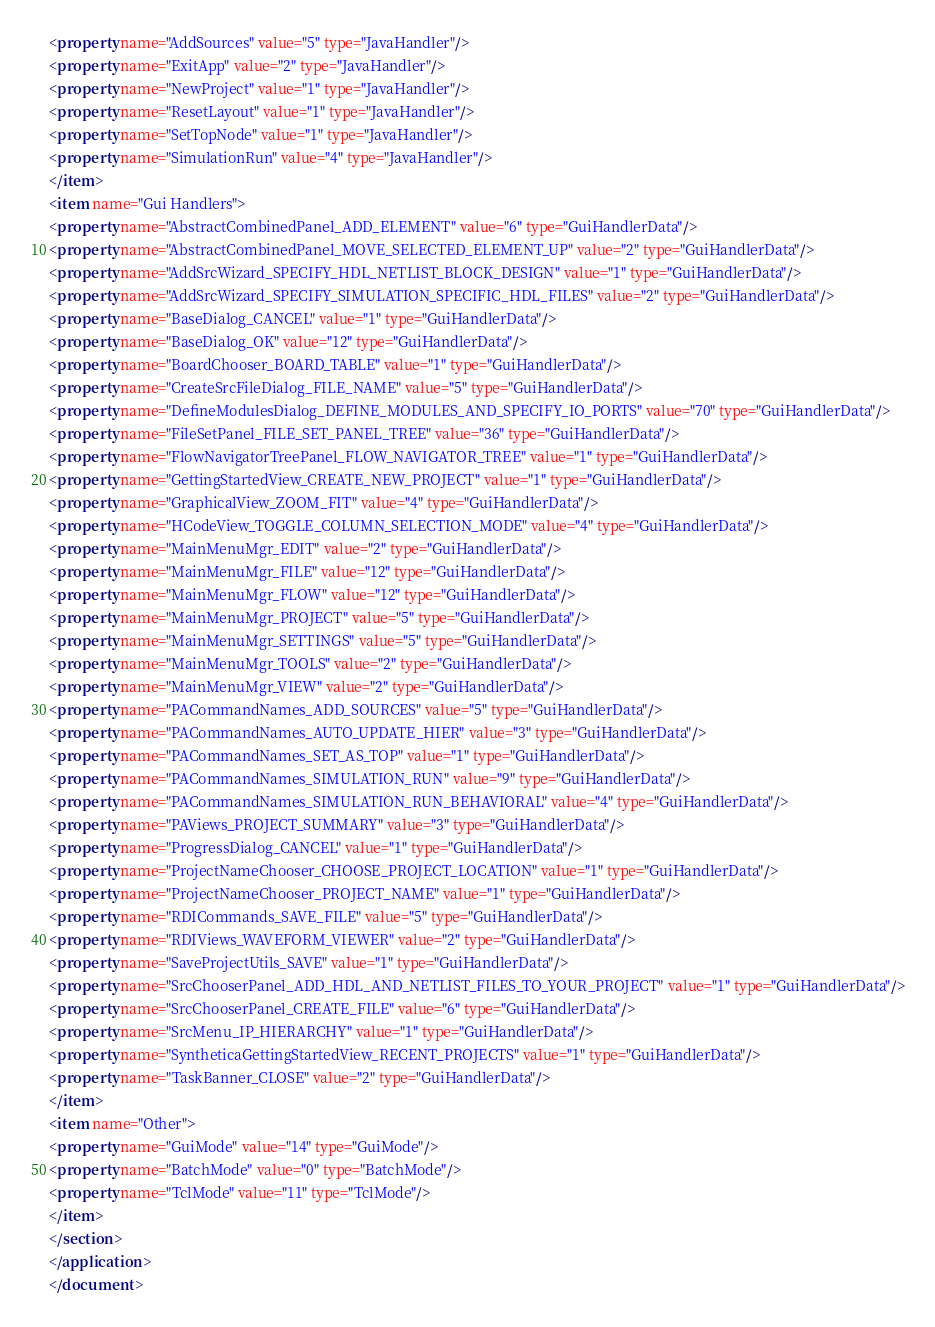Convert code to text. <code><loc_0><loc_0><loc_500><loc_500><_XML_><property name="AddSources" value="5" type="JavaHandler"/>
<property name="ExitApp" value="2" type="JavaHandler"/>
<property name="NewProject" value="1" type="JavaHandler"/>
<property name="ResetLayout" value="1" type="JavaHandler"/>
<property name="SetTopNode" value="1" type="JavaHandler"/>
<property name="SimulationRun" value="4" type="JavaHandler"/>
</item>
<item name="Gui Handlers">
<property name="AbstractCombinedPanel_ADD_ELEMENT" value="6" type="GuiHandlerData"/>
<property name="AbstractCombinedPanel_MOVE_SELECTED_ELEMENT_UP" value="2" type="GuiHandlerData"/>
<property name="AddSrcWizard_SPECIFY_HDL_NETLIST_BLOCK_DESIGN" value="1" type="GuiHandlerData"/>
<property name="AddSrcWizard_SPECIFY_SIMULATION_SPECIFIC_HDL_FILES" value="2" type="GuiHandlerData"/>
<property name="BaseDialog_CANCEL" value="1" type="GuiHandlerData"/>
<property name="BaseDialog_OK" value="12" type="GuiHandlerData"/>
<property name="BoardChooser_BOARD_TABLE" value="1" type="GuiHandlerData"/>
<property name="CreateSrcFileDialog_FILE_NAME" value="5" type="GuiHandlerData"/>
<property name="DefineModulesDialog_DEFINE_MODULES_AND_SPECIFY_IO_PORTS" value="70" type="GuiHandlerData"/>
<property name="FileSetPanel_FILE_SET_PANEL_TREE" value="36" type="GuiHandlerData"/>
<property name="FlowNavigatorTreePanel_FLOW_NAVIGATOR_TREE" value="1" type="GuiHandlerData"/>
<property name="GettingStartedView_CREATE_NEW_PROJECT" value="1" type="GuiHandlerData"/>
<property name="GraphicalView_ZOOM_FIT" value="4" type="GuiHandlerData"/>
<property name="HCodeView_TOGGLE_COLUMN_SELECTION_MODE" value="4" type="GuiHandlerData"/>
<property name="MainMenuMgr_EDIT" value="2" type="GuiHandlerData"/>
<property name="MainMenuMgr_FILE" value="12" type="GuiHandlerData"/>
<property name="MainMenuMgr_FLOW" value="12" type="GuiHandlerData"/>
<property name="MainMenuMgr_PROJECT" value="5" type="GuiHandlerData"/>
<property name="MainMenuMgr_SETTINGS" value="5" type="GuiHandlerData"/>
<property name="MainMenuMgr_TOOLS" value="2" type="GuiHandlerData"/>
<property name="MainMenuMgr_VIEW" value="2" type="GuiHandlerData"/>
<property name="PACommandNames_ADD_SOURCES" value="5" type="GuiHandlerData"/>
<property name="PACommandNames_AUTO_UPDATE_HIER" value="3" type="GuiHandlerData"/>
<property name="PACommandNames_SET_AS_TOP" value="1" type="GuiHandlerData"/>
<property name="PACommandNames_SIMULATION_RUN" value="9" type="GuiHandlerData"/>
<property name="PACommandNames_SIMULATION_RUN_BEHAVIORAL" value="4" type="GuiHandlerData"/>
<property name="PAViews_PROJECT_SUMMARY" value="3" type="GuiHandlerData"/>
<property name="ProgressDialog_CANCEL" value="1" type="GuiHandlerData"/>
<property name="ProjectNameChooser_CHOOSE_PROJECT_LOCATION" value="1" type="GuiHandlerData"/>
<property name="ProjectNameChooser_PROJECT_NAME" value="1" type="GuiHandlerData"/>
<property name="RDICommands_SAVE_FILE" value="5" type="GuiHandlerData"/>
<property name="RDIViews_WAVEFORM_VIEWER" value="2" type="GuiHandlerData"/>
<property name="SaveProjectUtils_SAVE" value="1" type="GuiHandlerData"/>
<property name="SrcChooserPanel_ADD_HDL_AND_NETLIST_FILES_TO_YOUR_PROJECT" value="1" type="GuiHandlerData"/>
<property name="SrcChooserPanel_CREATE_FILE" value="6" type="GuiHandlerData"/>
<property name="SrcMenu_IP_HIERARCHY" value="1" type="GuiHandlerData"/>
<property name="SyntheticaGettingStartedView_RECENT_PROJECTS" value="1" type="GuiHandlerData"/>
<property name="TaskBanner_CLOSE" value="2" type="GuiHandlerData"/>
</item>
<item name="Other">
<property name="GuiMode" value="14" type="GuiMode"/>
<property name="BatchMode" value="0" type="BatchMode"/>
<property name="TclMode" value="11" type="TclMode"/>
</item>
</section>
</application>
</document>
</code> 